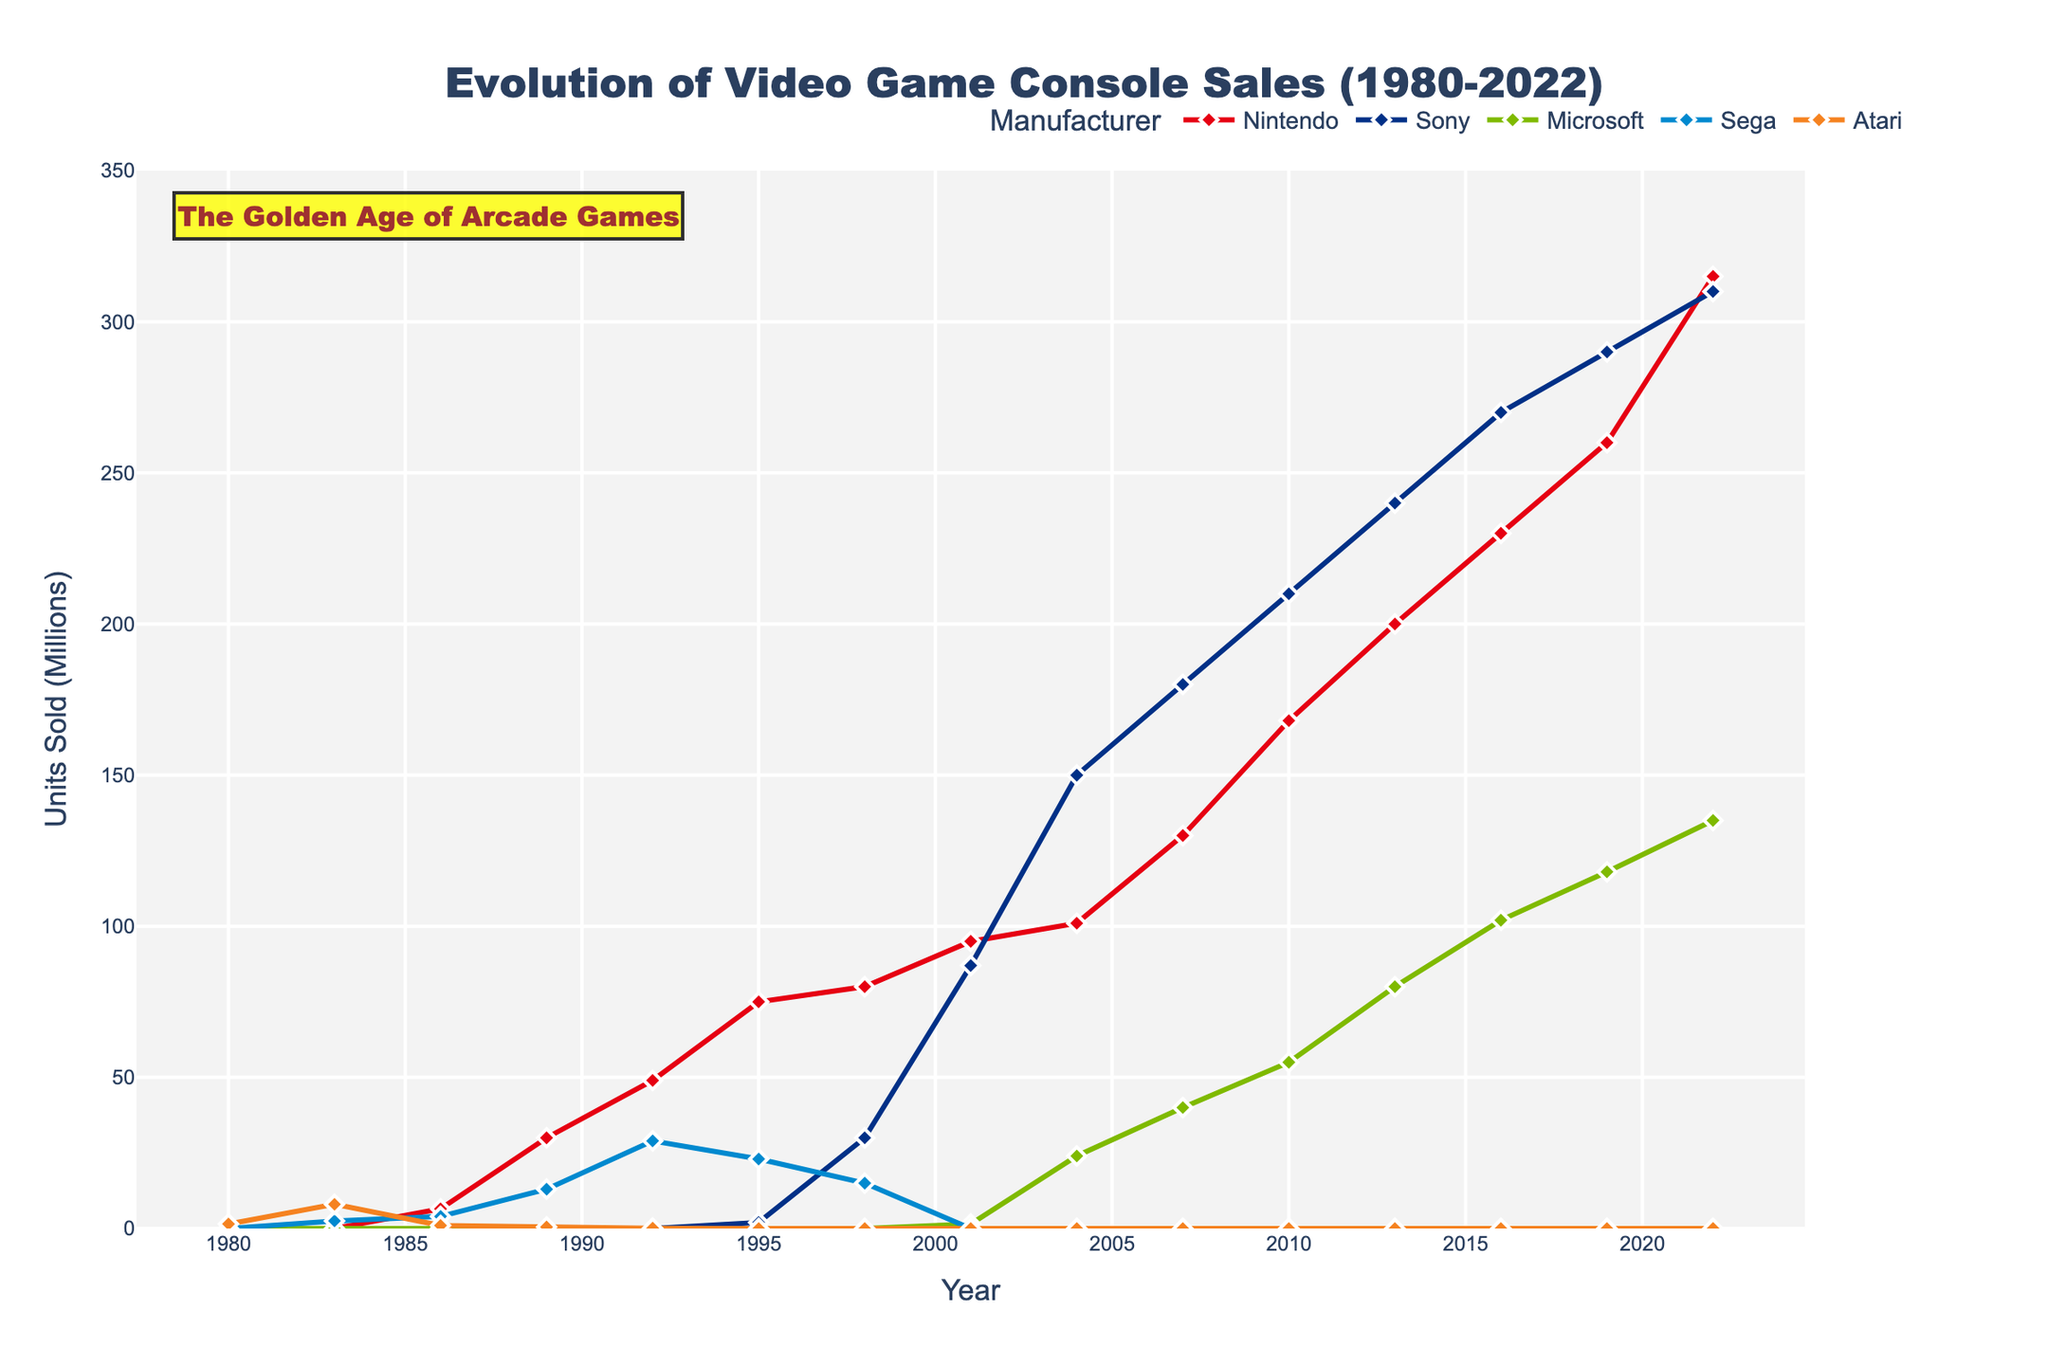What's the highest peak in Nintendo console sales? The highest point for Nintendo on the chart represents its peak sales. This occurs at the year 2022, reaching 315 million units.
Answer: 315 million units Which year saw the highest combined sales for Nintendo, Sony, and Microsoft? We need to sum the sales of Nintendo, Sony, and Microsoft for each year and find the highest total. The sales for 2022 are 315 (Nintendo) + 310 (Sony) + 135 (Microsoft) = 760 million units, which is the highest combined sales.
Answer: 2022 By how much did Microsoft's sales increase from 2001 to 2016? Subtract the sales of Microsoft in 2001 from its sales in 2016: 102 million units (2016) - 1.5 million units (2001) = 100.5 million units increase.
Answer: 100.5 million units In which year did Sony overtake Nintendo in sales for the first time? Sony's line first surpasses Nintendo's in the year 2004 with Sony at 150 million units and Nintendo at 101 million units.
Answer: 2004 Looking at the sales trend, which manufacturer's consoles showed a continuous rise from 1980 to 2022? Based on the chart, Nintendo's sales show a continuous upward trend from 1980 to 2022 without any significant dips.
Answer: Nintendo Compare Sega's console sales in the year 1983 with Atari in the same year. From the chart, Sega had sales of 2.5 million units in 1983, whereas Atari had 8 million units in the same year.
Answer: Atari (8 million units) What is the range of units sold by Sony throughout the entire period shown? The lowest sales figure for Sony is 2 million units in 1995, and the highest is 310 million units in 2022. Therefore, the range is 310 - 2 = 308 million units.
Answer: 308 million units Which manufacturer's sales dropped to zero first in the given timeline? From the chart, Sega's sales first dropped to zero units in the year 2001.
Answer: Sega 